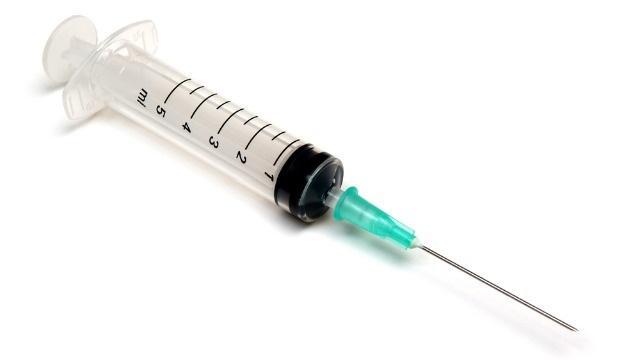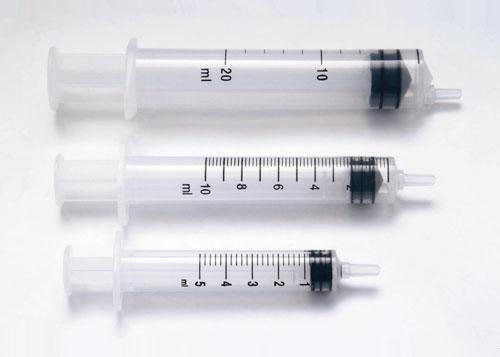The first image is the image on the left, the second image is the image on the right. Considering the images on both sides, is "There are more syringes in the image on the right." valid? Answer yes or no. Yes. The first image is the image on the left, the second image is the image on the right. For the images displayed, is the sentence "The right image includes more syringe-type tubes than the left image." factually correct? Answer yes or no. Yes. 